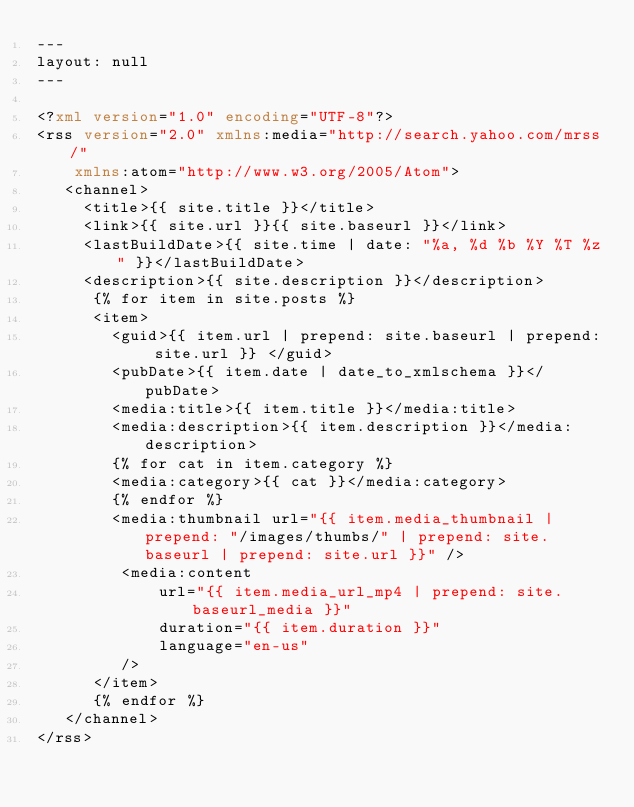Convert code to text. <code><loc_0><loc_0><loc_500><loc_500><_XML_>---
layout: null
---

<?xml version="1.0" encoding="UTF-8"?>
<rss version="2.0" xmlns:media="http://search.yahoo.com/mrss/"
    xmlns:atom="http://www.w3.org/2005/Atom">
   <channel>
     <title>{{ site.title }}</title>
     <link>{{ site.url }}{{ site.baseurl }}</link>
     <lastBuildDate>{{ site.time | date: "%a, %d %b %Y %T %z" }}</lastBuildDate>
     <description>{{ site.description }}</description>
      {% for item in site.posts %}
      <item>
        <guid>{{ item.url | prepend: site.baseurl | prepend: site.url }} </guid>
        <pubDate>{{ item.date | date_to_xmlschema }}</pubDate>
        <media:title>{{ item.title }}</media:title>
        <media:description>{{ item.description }}</media:description>
        {% for cat in item.category %}
        <media:category>{{ cat }}</media:category>
        {% endfor %}
        <media:thumbnail url="{{ item.media_thumbnail | prepend: "/images/thumbs/" | prepend: site.baseurl | prepend: site.url }}" />
         <media:content
             url="{{ item.media_url_mp4 | prepend: site.baseurl_media }}"
             duration="{{ item.duration }}"
             language="en-us"
         />
      </item>
      {% endfor %}
   </channel>
</rss>
</code> 